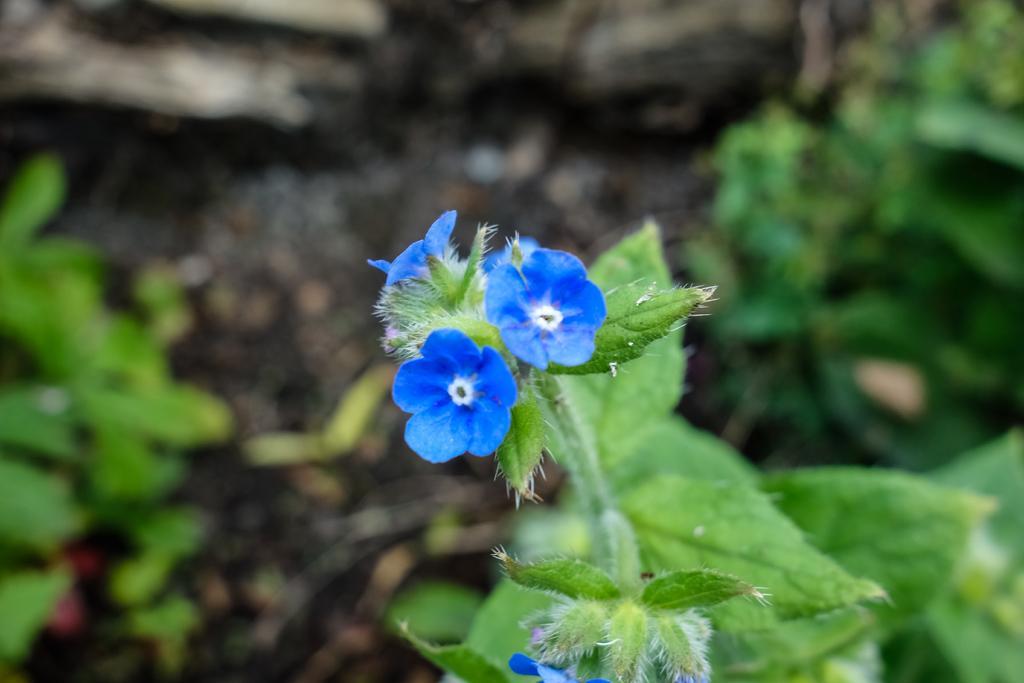Could you give a brief overview of what you see in this image? In this image there are flowers and plants and the background is blurry. 